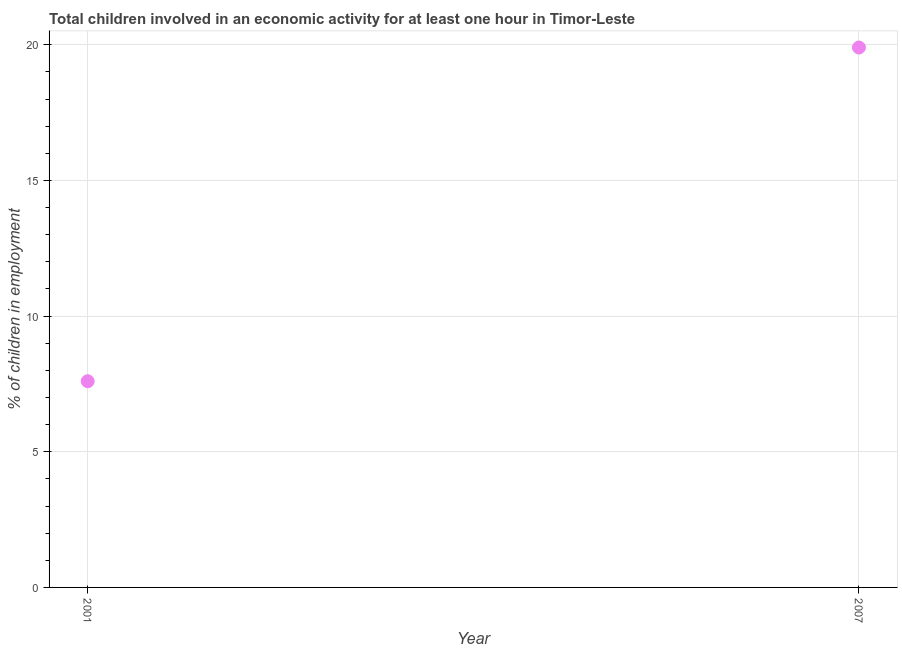Across all years, what is the maximum percentage of children in employment?
Make the answer very short. 19.9. Across all years, what is the minimum percentage of children in employment?
Your response must be concise. 7.6. What is the difference between the percentage of children in employment in 2001 and 2007?
Provide a short and direct response. -12.3. What is the average percentage of children in employment per year?
Make the answer very short. 13.75. What is the median percentage of children in employment?
Offer a terse response. 13.75. In how many years, is the percentage of children in employment greater than 6 %?
Offer a very short reply. 2. Do a majority of the years between 2007 and 2001 (inclusive) have percentage of children in employment greater than 16 %?
Give a very brief answer. No. What is the ratio of the percentage of children in employment in 2001 to that in 2007?
Your answer should be very brief. 0.38. Does the percentage of children in employment monotonically increase over the years?
Provide a succinct answer. Yes. How many dotlines are there?
Keep it short and to the point. 1. Does the graph contain any zero values?
Keep it short and to the point. No. Does the graph contain grids?
Your answer should be very brief. Yes. What is the title of the graph?
Keep it short and to the point. Total children involved in an economic activity for at least one hour in Timor-Leste. What is the label or title of the Y-axis?
Your answer should be very brief. % of children in employment. What is the % of children in employment in 2001?
Ensure brevity in your answer.  7.6. What is the difference between the % of children in employment in 2001 and 2007?
Make the answer very short. -12.3. What is the ratio of the % of children in employment in 2001 to that in 2007?
Provide a succinct answer. 0.38. 